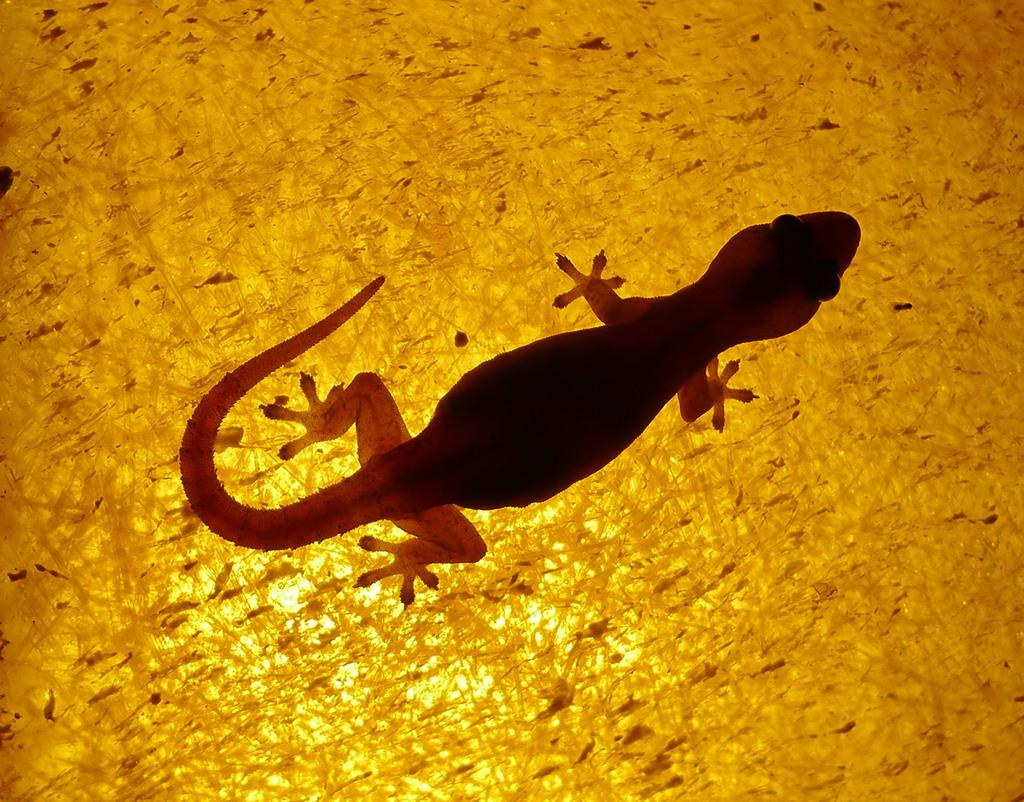What type of animal is in the image? There is a lizard in the image. Where is the lizard located? The lizard is on a surface. What type of mine is visible in the image? There is no mine present in the image; it features a lizard on a surface. What kind of trouble is the lizard causing in the image? There is no indication of the lizard causing any trouble in the image. 